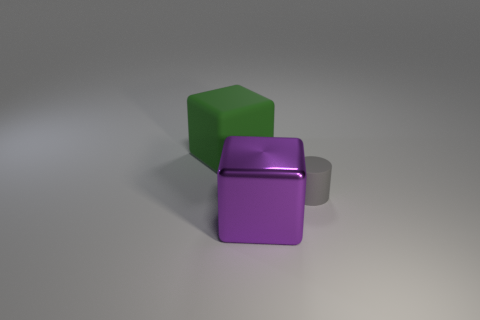Is the block that is right of the rubber cube made of the same material as the gray object? The block to the right of the rubber cube, which is the purple block, is not made from the same material as the gray object. The gray object has a metallic sheen indicating it's likely made of metal, while the purple block has a matte finish suggesting it is made of a different, non-metallic material. 